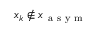<formula> <loc_0><loc_0><loc_500><loc_500>x _ { k } \notin x _ { a s y m }</formula> 